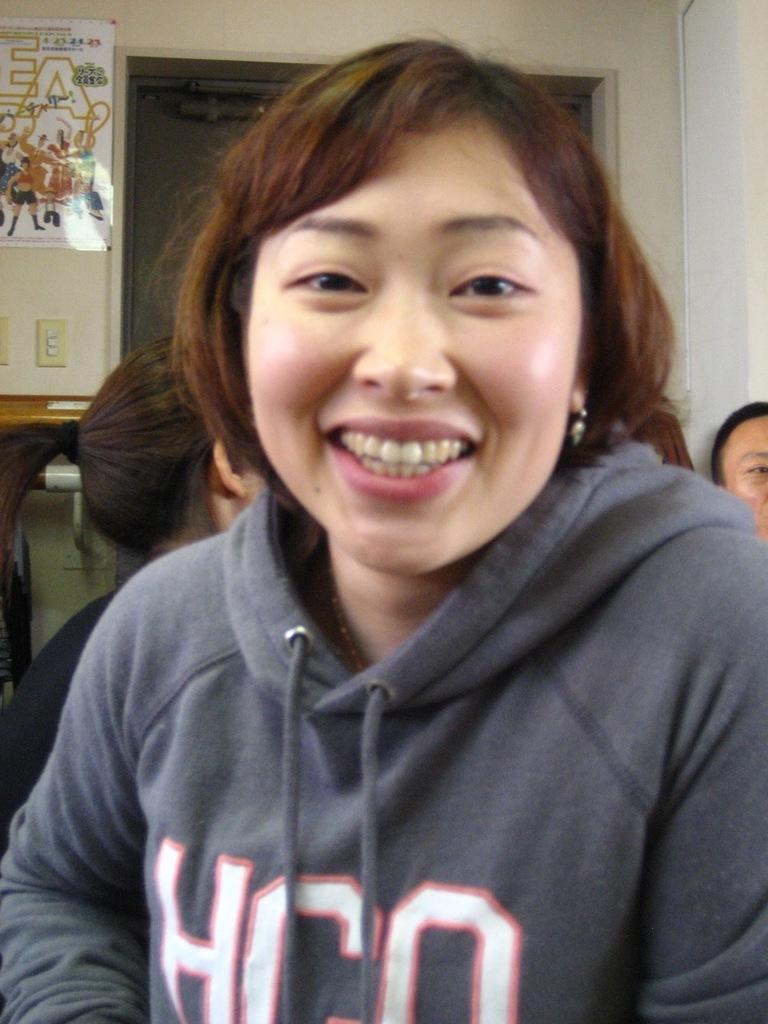In one or two sentences, can you explain what this image depicts? The picture is taken in a room. In the foreground of the picture there is a woman wearing hoodie. Behind her there is woman sitting. On the right there is a person. In the background there is door. On the left there is a poster to the wall. 